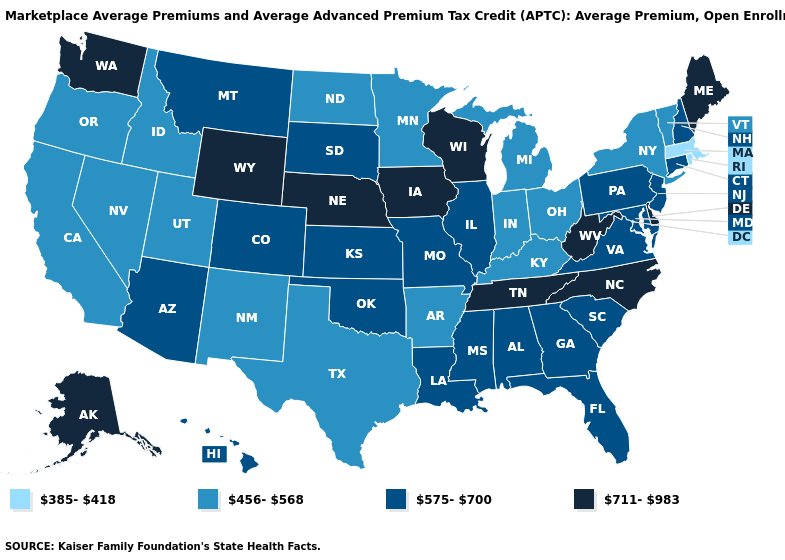What is the lowest value in states that border New York?
Short answer required. 385-418. Does Arkansas have the lowest value in the South?
Be succinct. Yes. Which states have the highest value in the USA?
Answer briefly. Alaska, Delaware, Iowa, Maine, Nebraska, North Carolina, Tennessee, Washington, West Virginia, Wisconsin, Wyoming. Does Maine have the highest value in the Northeast?
Concise answer only. Yes. What is the value of Virginia?
Answer briefly. 575-700. What is the lowest value in the USA?
Write a very short answer. 385-418. Name the states that have a value in the range 575-700?
Quick response, please. Alabama, Arizona, Colorado, Connecticut, Florida, Georgia, Hawaii, Illinois, Kansas, Louisiana, Maryland, Mississippi, Missouri, Montana, New Hampshire, New Jersey, Oklahoma, Pennsylvania, South Carolina, South Dakota, Virginia. Does the first symbol in the legend represent the smallest category?
Keep it brief. Yes. Name the states that have a value in the range 575-700?
Answer briefly. Alabama, Arizona, Colorado, Connecticut, Florida, Georgia, Hawaii, Illinois, Kansas, Louisiana, Maryland, Mississippi, Missouri, Montana, New Hampshire, New Jersey, Oklahoma, Pennsylvania, South Carolina, South Dakota, Virginia. What is the highest value in states that border Mississippi?
Keep it brief. 711-983. Among the states that border Idaho , does Montana have the lowest value?
Concise answer only. No. Is the legend a continuous bar?
Quick response, please. No. What is the value of Alaska?
Write a very short answer. 711-983. Name the states that have a value in the range 456-568?
Concise answer only. Arkansas, California, Idaho, Indiana, Kentucky, Michigan, Minnesota, Nevada, New Mexico, New York, North Dakota, Ohio, Oregon, Texas, Utah, Vermont. Which states have the lowest value in the West?
Write a very short answer. California, Idaho, Nevada, New Mexico, Oregon, Utah. 